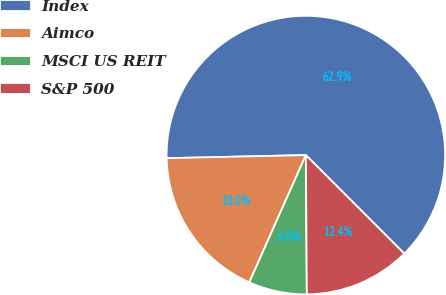Convert chart. <chart><loc_0><loc_0><loc_500><loc_500><pie_chart><fcel>Index<fcel>Aimco<fcel>MSCI US REIT<fcel>S&P 500<nl><fcel>62.87%<fcel>17.99%<fcel>6.77%<fcel>12.38%<nl></chart> 